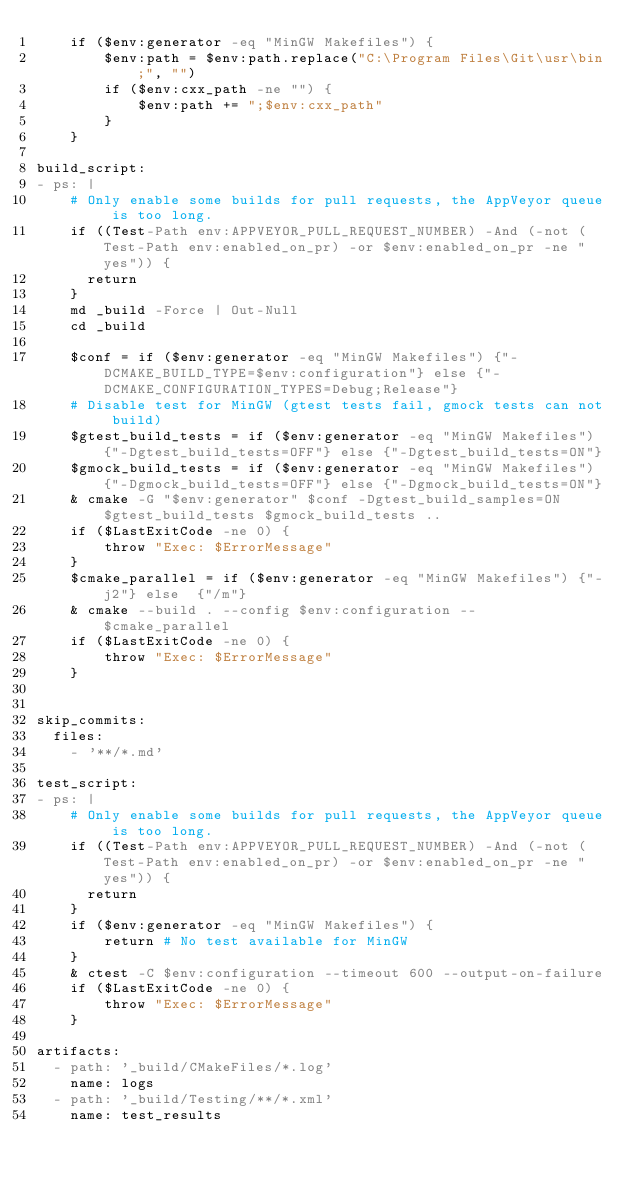Convert code to text. <code><loc_0><loc_0><loc_500><loc_500><_YAML_>    if ($env:generator -eq "MinGW Makefiles") {
        $env:path = $env:path.replace("C:\Program Files\Git\usr\bin;", "")
        if ($env:cxx_path -ne "") {
            $env:path += ";$env:cxx_path"
        }
    }

build_script:
- ps: |
    # Only enable some builds for pull requests, the AppVeyor queue is too long.
    if ((Test-Path env:APPVEYOR_PULL_REQUEST_NUMBER) -And (-not (Test-Path env:enabled_on_pr) -or $env:enabled_on_pr -ne "yes")) {
      return
    }
    md _build -Force | Out-Null
    cd _build

    $conf = if ($env:generator -eq "MinGW Makefiles") {"-DCMAKE_BUILD_TYPE=$env:configuration"} else {"-DCMAKE_CONFIGURATION_TYPES=Debug;Release"}
    # Disable test for MinGW (gtest tests fail, gmock tests can not build)
    $gtest_build_tests = if ($env:generator -eq "MinGW Makefiles") {"-Dgtest_build_tests=OFF"} else {"-Dgtest_build_tests=ON"}
    $gmock_build_tests = if ($env:generator -eq "MinGW Makefiles") {"-Dgmock_build_tests=OFF"} else {"-Dgmock_build_tests=ON"}
    & cmake -G "$env:generator" $conf -Dgtest_build_samples=ON $gtest_build_tests $gmock_build_tests ..
    if ($LastExitCode -ne 0) {
        throw "Exec: $ErrorMessage"
    }
    $cmake_parallel = if ($env:generator -eq "MinGW Makefiles") {"-j2"} else  {"/m"}
    & cmake --build . --config $env:configuration -- $cmake_parallel
    if ($LastExitCode -ne 0) {
        throw "Exec: $ErrorMessage"
    }


skip_commits:
  files:
    - '**/*.md'

test_script:
- ps: |
    # Only enable some builds for pull requests, the AppVeyor queue is too long.
    if ((Test-Path env:APPVEYOR_PULL_REQUEST_NUMBER) -And (-not (Test-Path env:enabled_on_pr) -or $env:enabled_on_pr -ne "yes")) {
      return
    }
    if ($env:generator -eq "MinGW Makefiles") {
        return # No test available for MinGW
    }
    & ctest -C $env:configuration --timeout 600 --output-on-failure
    if ($LastExitCode -ne 0) {
        throw "Exec: $ErrorMessage"
    }

artifacts:
  - path: '_build/CMakeFiles/*.log'
    name: logs
  - path: '_build/Testing/**/*.xml'
    name: test_results
</code> 